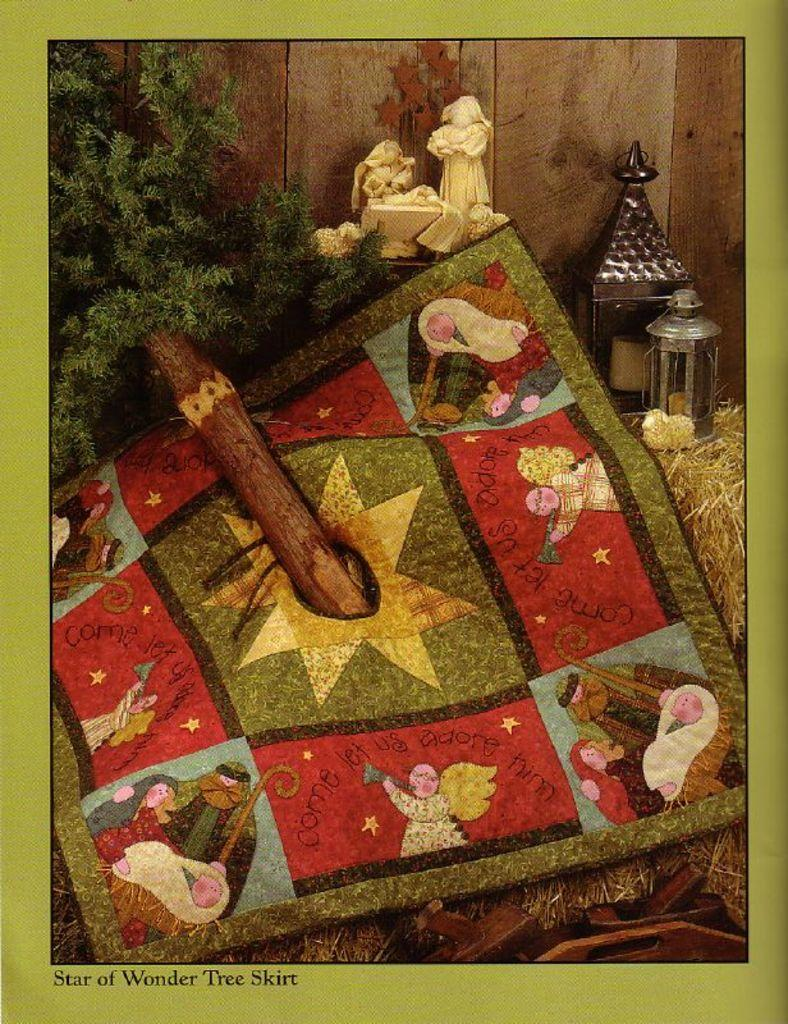What type of vegetation is present in the image? The image contains dry grass. What material is featured in the image? There is cloth in the image. What seasonal decoration can be seen in the image? There is a Christmas tree in the image. What type of artwork is present in the image? Sculptures are present in the image. What is the background of the image made of? The background of the image consists of a wooden wall. What color is the border around the image? The image has a green border. What type of belief is represented by the faucet in the image? There is no faucet present in the image, so it is not possible to determine any beliefs represented by it. 